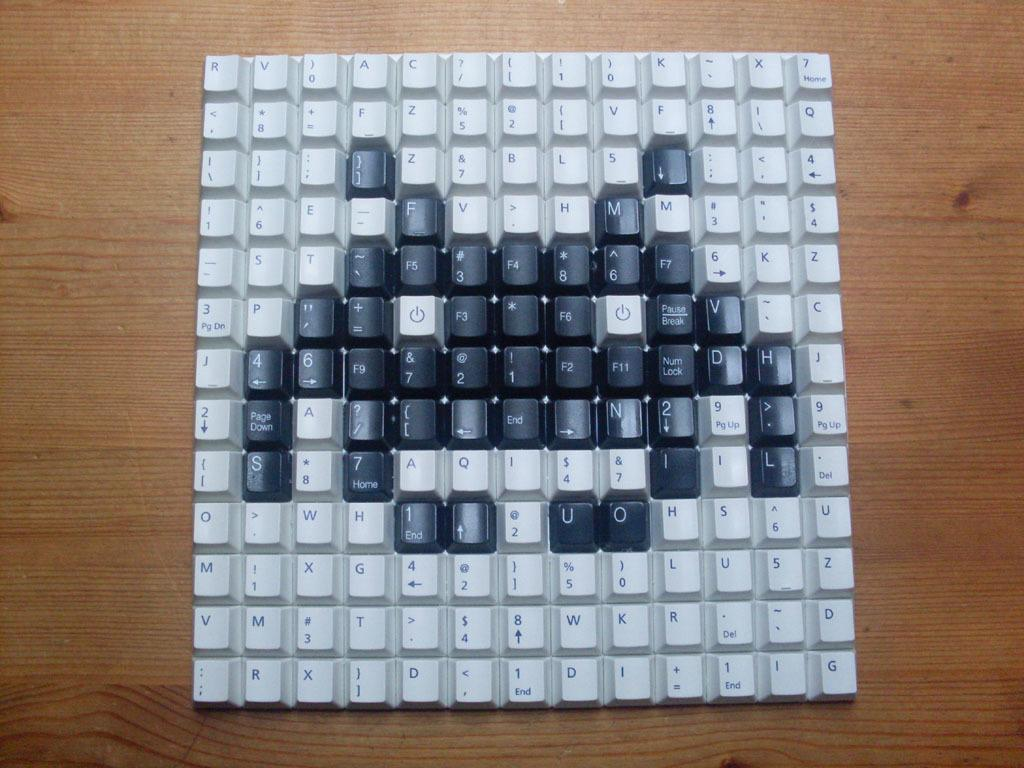<image>
Provide a brief description of the given image. black ans white keys have been removed from a keyboard and the black ones have been used to make an alien, including U and O in the bottom right. 